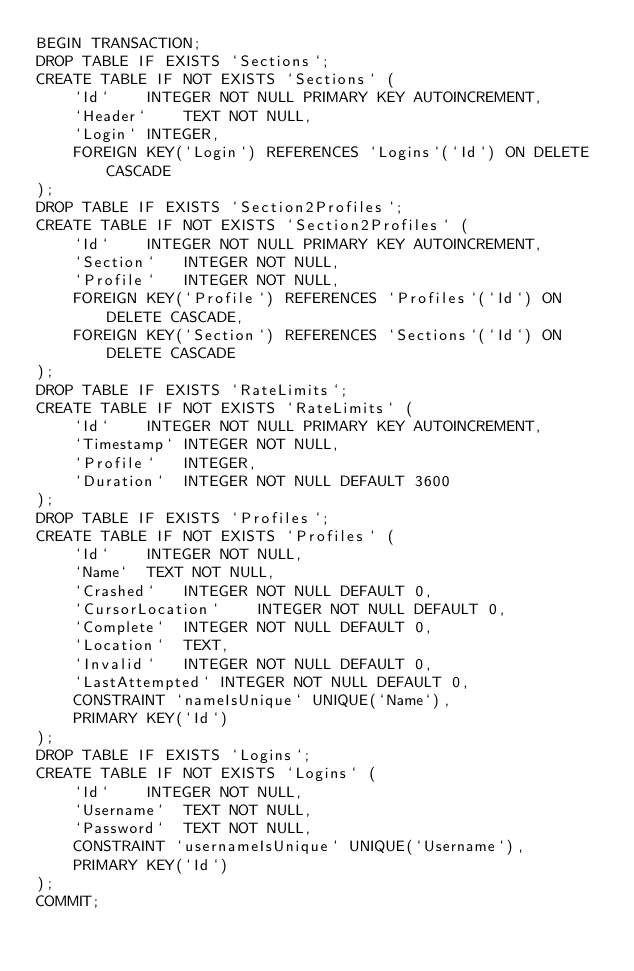Convert code to text. <code><loc_0><loc_0><loc_500><loc_500><_SQL_>BEGIN TRANSACTION;
DROP TABLE IF EXISTS `Sections`;
CREATE TABLE IF NOT EXISTS `Sections` (
	`Id`	INTEGER NOT NULL PRIMARY KEY AUTOINCREMENT,
	`Header`	TEXT NOT NULL,
	`Login`	INTEGER,
	FOREIGN KEY(`Login`) REFERENCES `Logins`(`Id`) ON DELETE CASCADE
);
DROP TABLE IF EXISTS `Section2Profiles`;
CREATE TABLE IF NOT EXISTS `Section2Profiles` (
	`Id`	INTEGER NOT NULL PRIMARY KEY AUTOINCREMENT,
	`Section`	INTEGER NOT NULL,
	`Profile`	INTEGER NOT NULL,
	FOREIGN KEY(`Profile`) REFERENCES `Profiles`(`Id`) ON DELETE CASCADE,
	FOREIGN KEY(`Section`) REFERENCES `Sections`(`Id`) ON DELETE CASCADE
);
DROP TABLE IF EXISTS `RateLimits`;
CREATE TABLE IF NOT EXISTS `RateLimits` (
	`Id`	INTEGER NOT NULL PRIMARY KEY AUTOINCREMENT,
	`Timestamp`	INTEGER NOT NULL,
	`Profile`	INTEGER,
	`Duration`	INTEGER NOT NULL DEFAULT 3600
);
DROP TABLE IF EXISTS `Profiles`;
CREATE TABLE IF NOT EXISTS `Profiles` (
	`Id`	INTEGER NOT NULL,
	`Name`	TEXT NOT NULL,
	`Crashed`	INTEGER NOT NULL DEFAULT 0,
	`CursorLocation`	INTEGER NOT NULL DEFAULT 0,
	`Complete`	INTEGER NOT NULL DEFAULT 0,
	`Location`	TEXT,
	`Invalid`	INTEGER NOT NULL DEFAULT 0,
	`LastAttempted`	INTEGER NOT NULL DEFAULT 0,
	CONSTRAINT `nameIsUnique` UNIQUE(`Name`),
	PRIMARY KEY(`Id`)
);
DROP TABLE IF EXISTS `Logins`;
CREATE TABLE IF NOT EXISTS `Logins` (
	`Id`	INTEGER NOT NULL,
	`Username`	TEXT NOT NULL,
	`Password`	TEXT NOT NULL,
	CONSTRAINT `usernameIsUnique` UNIQUE(`Username`),
	PRIMARY KEY(`Id`)
);
COMMIT;
</code> 